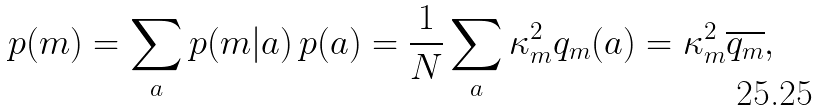<formula> <loc_0><loc_0><loc_500><loc_500>p ( m ) = \sum _ { a } p ( m | a ) \, p ( a ) = \frac { 1 } { N } \sum _ { a } \kappa _ { m } ^ { 2 } q _ { m } ( a ) = \kappa _ { m } ^ { 2 } \overline { q _ { m } } ,</formula> 